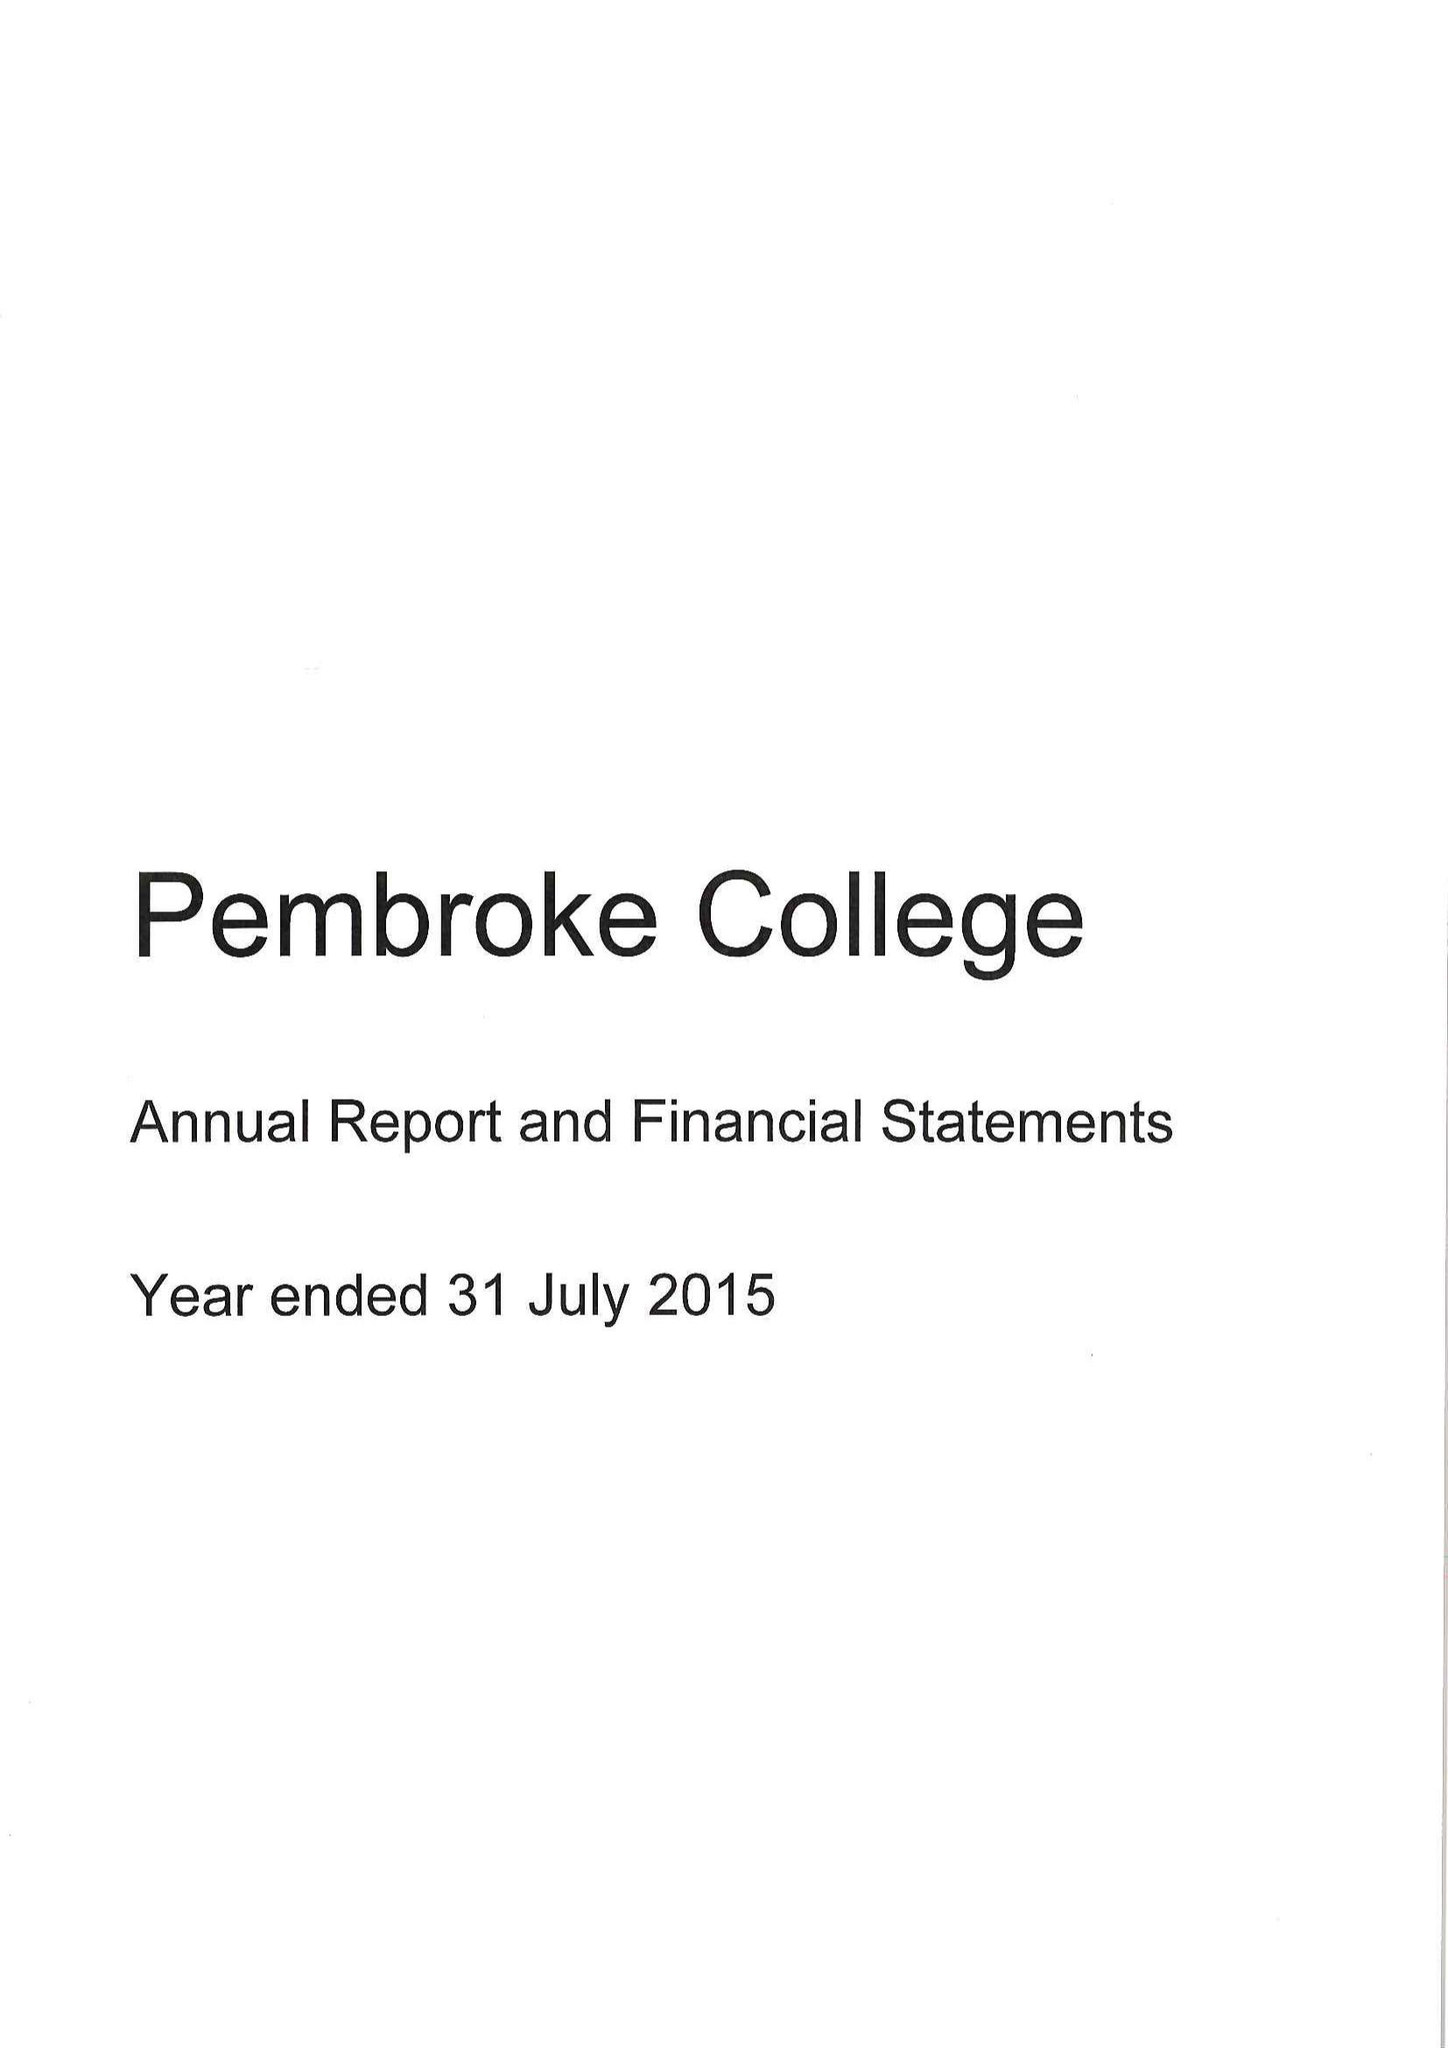What is the value for the address__postcode?
Answer the question using a single word or phrase. OX1 1DW 